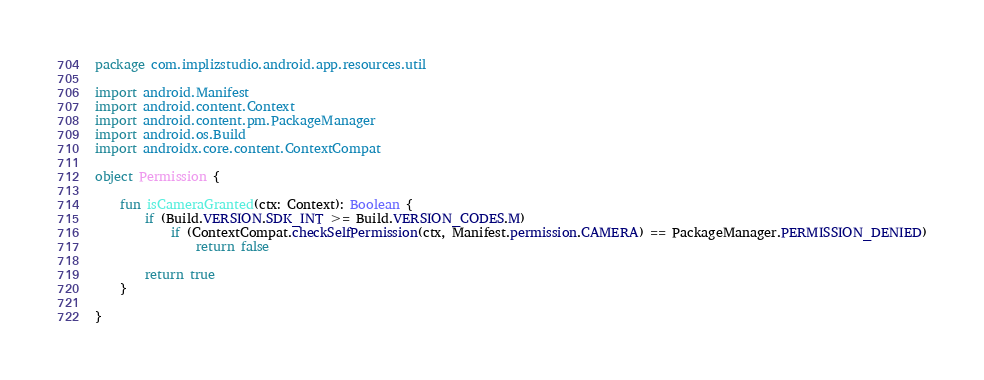Convert code to text. <code><loc_0><loc_0><loc_500><loc_500><_Kotlin_>package com.implizstudio.android.app.resources.util

import android.Manifest
import android.content.Context
import android.content.pm.PackageManager
import android.os.Build
import androidx.core.content.ContextCompat

object Permission {

    fun isCameraGranted(ctx: Context): Boolean {
        if (Build.VERSION.SDK_INT >= Build.VERSION_CODES.M)
            if (ContextCompat.checkSelfPermission(ctx, Manifest.permission.CAMERA) == PackageManager.PERMISSION_DENIED)
                return false

        return true
    }

}</code> 